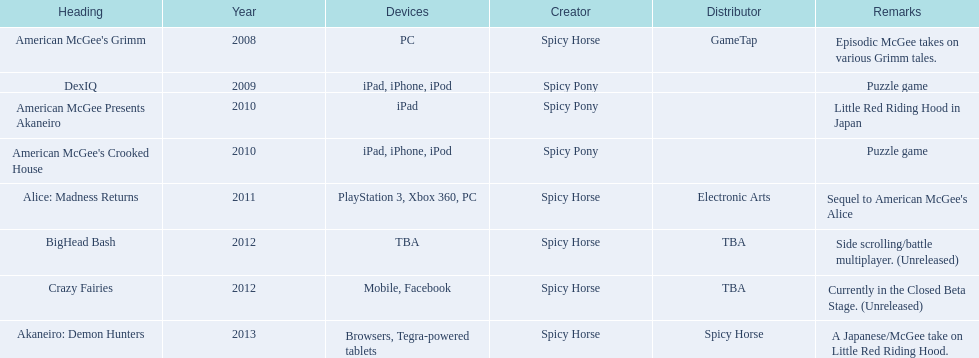What year witnessed the release of 2 titles in total? 2010. 